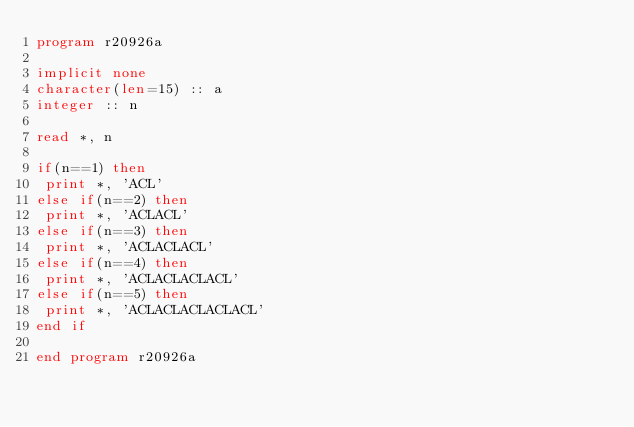<code> <loc_0><loc_0><loc_500><loc_500><_FORTRAN_>program r20926a
 
implicit none
character(len=15) :: a
integer :: n

read *, n

if(n==1) then
 print *, 'ACL'
else if(n==2) then
 print *, 'ACLACL'
else if(n==3) then
 print *, 'ACLACLACL'
else if(n==4) then
 print *, 'ACLACLACLACL'
else if(n==5) then
 print *, 'ACLACLACLACLACL'
end if

end program r20926a</code> 